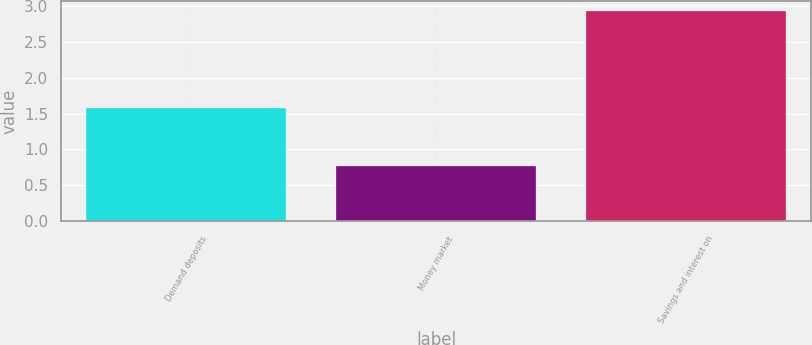<chart> <loc_0><loc_0><loc_500><loc_500><bar_chart><fcel>Demand deposits<fcel>Money market<fcel>Savings and interest on<nl><fcel>1.57<fcel>0.77<fcel>2.92<nl></chart> 